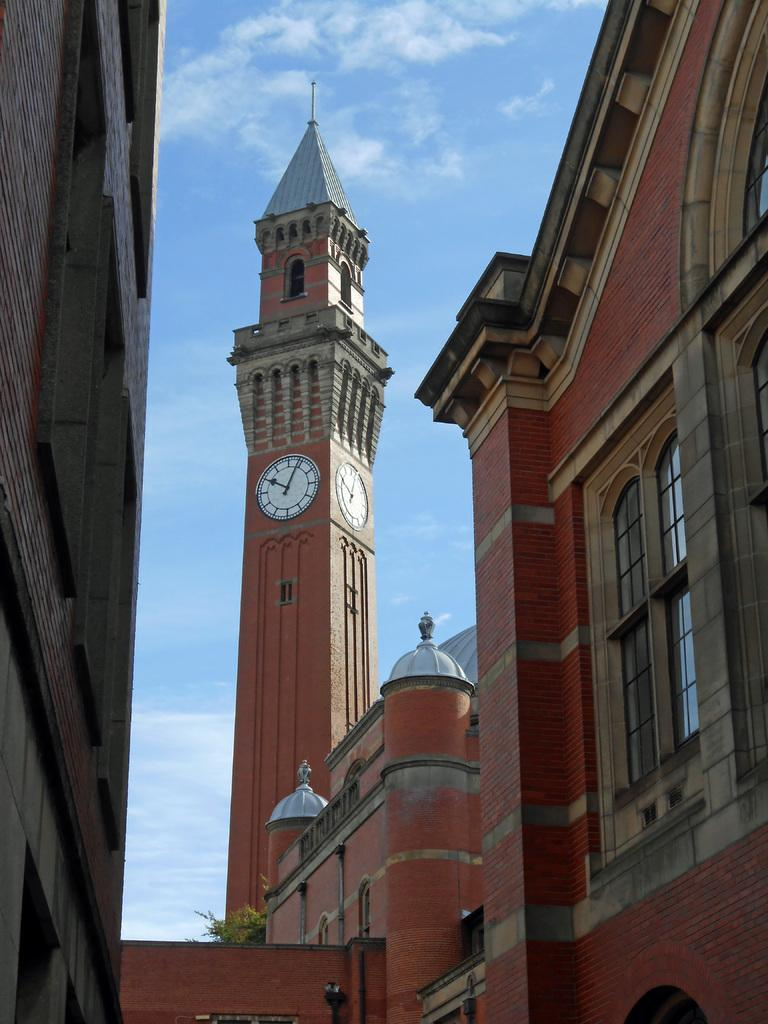What type of structure is visible in the image? There is a building with windows in the image. What is located on top of the building? There is a tower with a watch in the image. What type of vegetation can be seen in the image? There are trees in the image. What is visible in the background of the image? The sky is visible in the image, and clouds are present in the sky. How many cakes are being served in the image? There are no cakes present in the image. What type of needle is being used to sew the town in the image? There is no town or needle present in the image. 